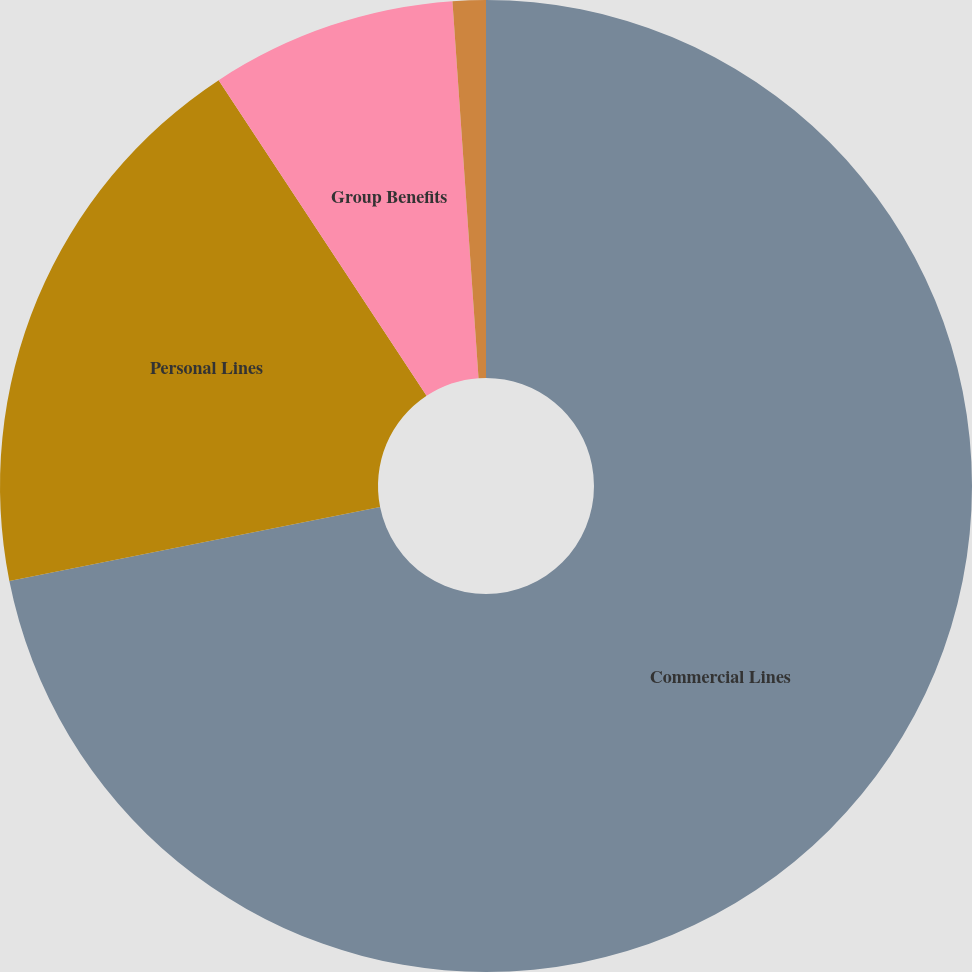<chart> <loc_0><loc_0><loc_500><loc_500><pie_chart><fcel>Commercial Lines<fcel>Personal Lines<fcel>Group Benefits<fcel>Hartford Funds<nl><fcel>71.87%<fcel>18.86%<fcel>8.17%<fcel>1.1%<nl></chart> 